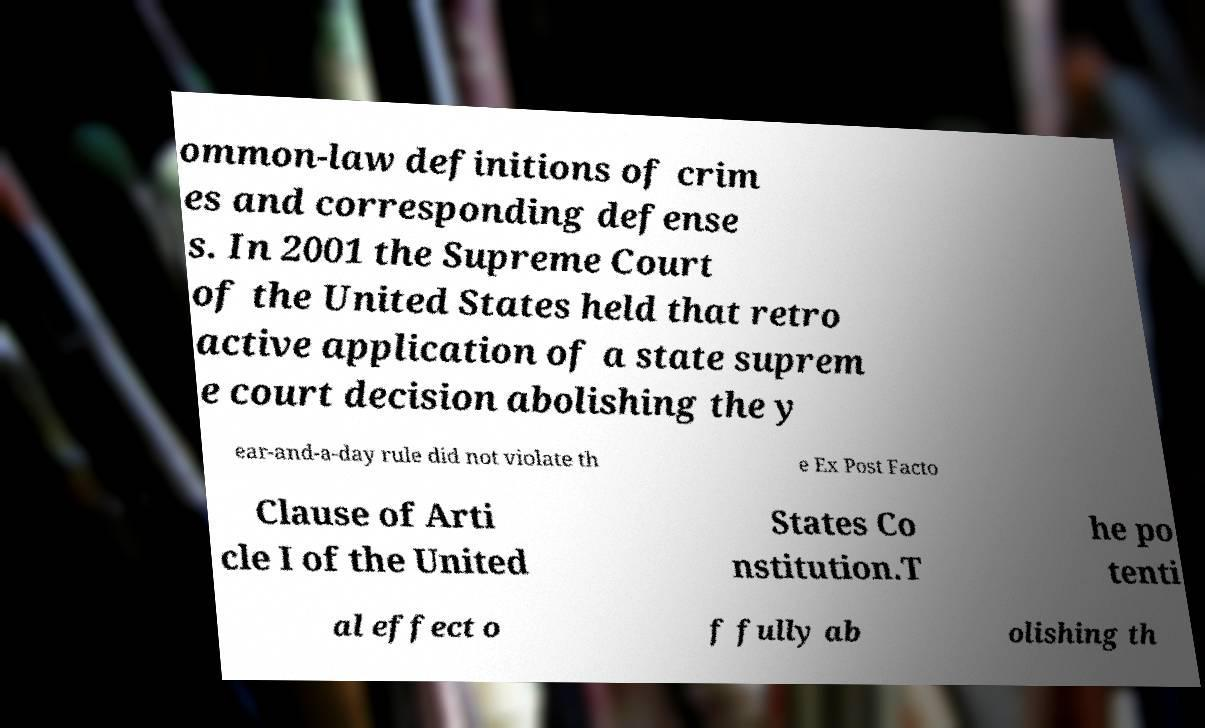Could you extract and type out the text from this image? ommon-law definitions of crim es and corresponding defense s. In 2001 the Supreme Court of the United States held that retro active application of a state suprem e court decision abolishing the y ear-and-a-day rule did not violate th e Ex Post Facto Clause of Arti cle I of the United States Co nstitution.T he po tenti al effect o f fully ab olishing th 